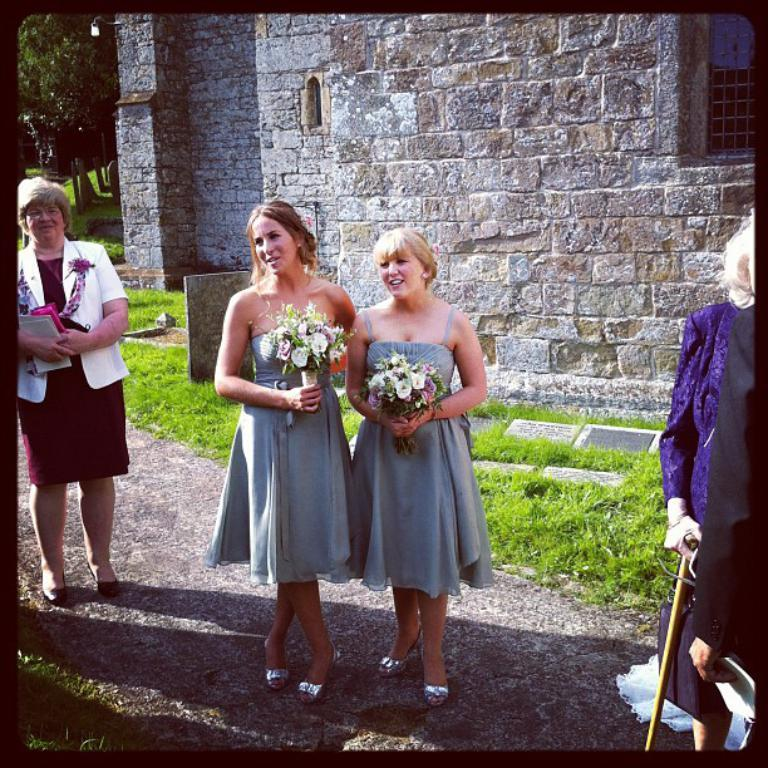What are the people in the image doing? The people in the image are standing and holding objects. What can be seen in the background of the image? There are trees, grass, windows, and a wall in the background of the image. What type of faucet can be seen in the image? There is no faucet present in the image. Can you tell me how many ghosts are visible in the image? There are no ghosts visible in the image. 